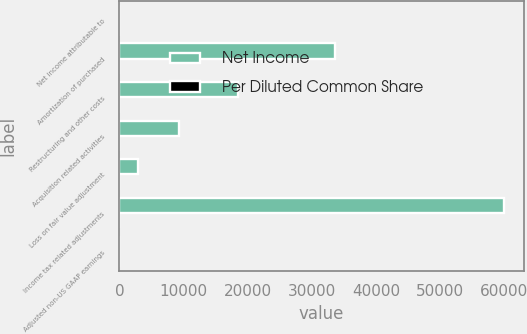Convert chart. <chart><loc_0><loc_0><loc_500><loc_500><stacked_bar_chart><ecel><fcel>Net income attributable to<fcel>Amortization of purchased<fcel>Restructuring and other costs<fcel>Acquisition related activities<fcel>Loss on fair value adjustment<fcel>Income tax related adjustments<fcel>Adjusted non-US GAAP earnings<nl><fcel>Net Income<fcel>2.2<fcel>33612<fcel>18549<fcel>9299<fcel>2927<fcel>59992<fcel>2.2<nl><fcel>Per Diluted Common Share<fcel>2.18<fcel>0.23<fcel>0.13<fcel>0.07<fcel>0.02<fcel>0.41<fcel>2.22<nl></chart> 